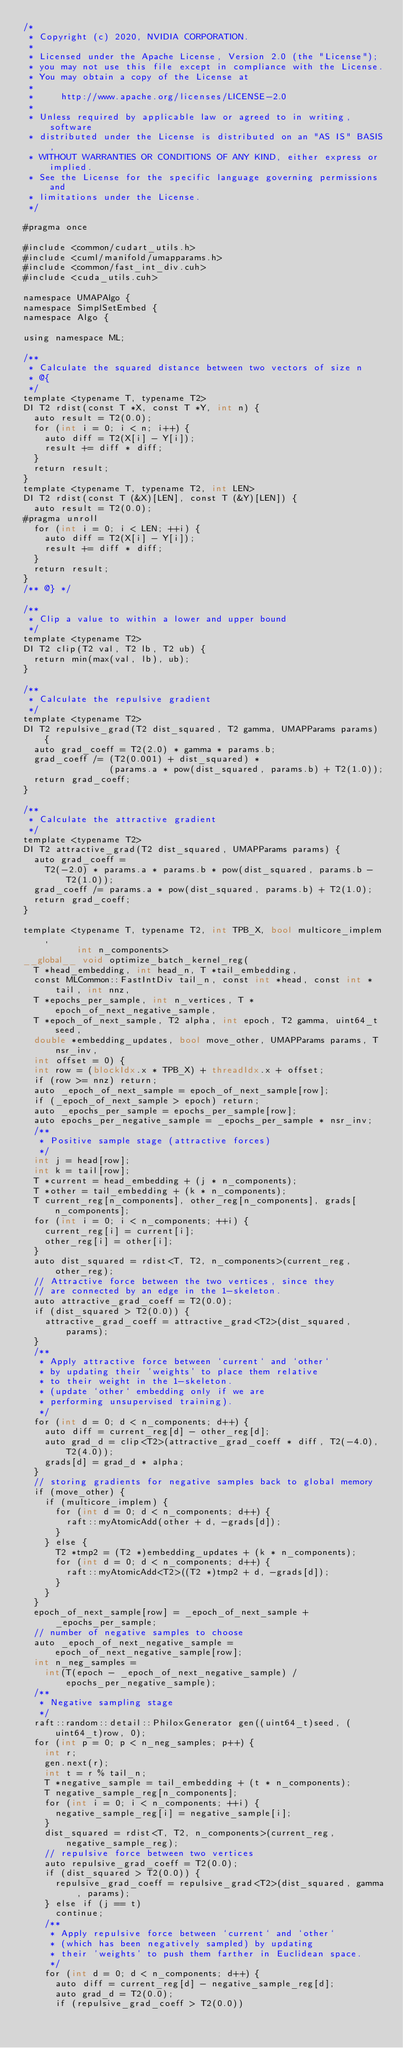Convert code to text. <code><loc_0><loc_0><loc_500><loc_500><_Cuda_>/*
 * Copyright (c) 2020, NVIDIA CORPORATION.
 *
 * Licensed under the Apache License, Version 2.0 (the "License");
 * you may not use this file except in compliance with the License.
 * You may obtain a copy of the License at
 *
 *     http://www.apache.org/licenses/LICENSE-2.0
 *
 * Unless required by applicable law or agreed to in writing, software
 * distributed under the License is distributed on an "AS IS" BASIS,
 * WITHOUT WARRANTIES OR CONDITIONS OF ANY KIND, either express or implied.
 * See the License for the specific language governing permissions and
 * limitations under the License.
 */

#pragma once

#include <common/cudart_utils.h>
#include <cuml/manifold/umapparams.h>
#include <common/fast_int_div.cuh>
#include <cuda_utils.cuh>

namespace UMAPAlgo {
namespace SimplSetEmbed {
namespace Algo {

using namespace ML;

/**
 * Calculate the squared distance between two vectors of size n
 * @{
 */
template <typename T, typename T2>
DI T2 rdist(const T *X, const T *Y, int n) {
  auto result = T2(0.0);
  for (int i = 0; i < n; i++) {
    auto diff = T2(X[i] - Y[i]);
    result += diff * diff;
  }
  return result;
}
template <typename T, typename T2, int LEN>
DI T2 rdist(const T (&X)[LEN], const T (&Y)[LEN]) {
  auto result = T2(0.0);
#pragma unroll
  for (int i = 0; i < LEN; ++i) {
    auto diff = T2(X[i] - Y[i]);
    result += diff * diff;
  }
  return result;
}
/** @} */

/**
 * Clip a value to within a lower and upper bound
 */
template <typename T2>
DI T2 clip(T2 val, T2 lb, T2 ub) {
  return min(max(val, lb), ub);
}

/**
 * Calculate the repulsive gradient
 */
template <typename T2>
DI T2 repulsive_grad(T2 dist_squared, T2 gamma, UMAPParams params) {
  auto grad_coeff = T2(2.0) * gamma * params.b;
  grad_coeff /= (T2(0.001) + dist_squared) *
                (params.a * pow(dist_squared, params.b) + T2(1.0));
  return grad_coeff;
}

/**
 * Calculate the attractive gradient
 */
template <typename T2>
DI T2 attractive_grad(T2 dist_squared, UMAPParams params) {
  auto grad_coeff =
    T2(-2.0) * params.a * params.b * pow(dist_squared, params.b - T2(1.0));
  grad_coeff /= params.a * pow(dist_squared, params.b) + T2(1.0);
  return grad_coeff;
}

template <typename T, typename T2, int TPB_X, bool multicore_implem,
          int n_components>
__global__ void optimize_batch_kernel_reg(
  T *head_embedding, int head_n, T *tail_embedding,
  const MLCommon::FastIntDiv tail_n, const int *head, const int *tail, int nnz,
  T *epochs_per_sample, int n_vertices, T *epoch_of_next_negative_sample,
  T *epoch_of_next_sample, T2 alpha, int epoch, T2 gamma, uint64_t seed,
  double *embedding_updates, bool move_other, UMAPParams params, T nsr_inv,
  int offset = 0) {
  int row = (blockIdx.x * TPB_X) + threadIdx.x + offset;
  if (row >= nnz) return;
  auto _epoch_of_next_sample = epoch_of_next_sample[row];
  if (_epoch_of_next_sample > epoch) return;
  auto _epochs_per_sample = epochs_per_sample[row];
  auto epochs_per_negative_sample = _epochs_per_sample * nsr_inv;
  /**
   * Positive sample stage (attractive forces)
   */
  int j = head[row];
  int k = tail[row];
  T *current = head_embedding + (j * n_components);
  T *other = tail_embedding + (k * n_components);
  T current_reg[n_components], other_reg[n_components], grads[n_components];
  for (int i = 0; i < n_components; ++i) {
    current_reg[i] = current[i];
    other_reg[i] = other[i];
  }
  auto dist_squared = rdist<T, T2, n_components>(current_reg, other_reg);
  // Attractive force between the two vertices, since they
  // are connected by an edge in the 1-skeleton.
  auto attractive_grad_coeff = T2(0.0);
  if (dist_squared > T2(0.0)) {
    attractive_grad_coeff = attractive_grad<T2>(dist_squared, params);
  }
  /**
   * Apply attractive force between `current` and `other`
   * by updating their 'weights' to place them relative
   * to their weight in the 1-skeleton.
   * (update `other` embedding only if we are
   * performing unsupervised training).
   */
  for (int d = 0; d < n_components; d++) {
    auto diff = current_reg[d] - other_reg[d];
    auto grad_d = clip<T2>(attractive_grad_coeff * diff, T2(-4.0), T2(4.0));
    grads[d] = grad_d * alpha;
  }
  // storing gradients for negative samples back to global memory
  if (move_other) {
    if (multicore_implem) {
      for (int d = 0; d < n_components; d++) {
        raft::myAtomicAdd(other + d, -grads[d]);
      }
    } else {
      T2 *tmp2 = (T2 *)embedding_updates + (k * n_components);
      for (int d = 0; d < n_components; d++) {
        raft::myAtomicAdd<T2>((T2 *)tmp2 + d, -grads[d]);
      }
    }
  }
  epoch_of_next_sample[row] = _epoch_of_next_sample + _epochs_per_sample;
  // number of negative samples to choose
  auto _epoch_of_next_negative_sample = epoch_of_next_negative_sample[row];
  int n_neg_samples =
    int(T(epoch - _epoch_of_next_negative_sample) / epochs_per_negative_sample);
  /**
   * Negative sampling stage
   */
  raft::random::detail::PhiloxGenerator gen((uint64_t)seed, (uint64_t)row, 0);
  for (int p = 0; p < n_neg_samples; p++) {
    int r;
    gen.next(r);
    int t = r % tail_n;
    T *negative_sample = tail_embedding + (t * n_components);
    T negative_sample_reg[n_components];
    for (int i = 0; i < n_components; ++i) {
      negative_sample_reg[i] = negative_sample[i];
    }
    dist_squared = rdist<T, T2, n_components>(current_reg, negative_sample_reg);
    // repulsive force between two vertices
    auto repulsive_grad_coeff = T2(0.0);
    if (dist_squared > T2(0.0)) {
      repulsive_grad_coeff = repulsive_grad<T2>(dist_squared, gamma, params);
    } else if (j == t)
      continue;
    /**
     * Apply repulsive force between `current` and `other`
     * (which has been negatively sampled) by updating
     * their 'weights' to push them farther in Euclidean space.
     */
    for (int d = 0; d < n_components; d++) {
      auto diff = current_reg[d] - negative_sample_reg[d];
      auto grad_d = T2(0.0);
      if (repulsive_grad_coeff > T2(0.0))</code> 